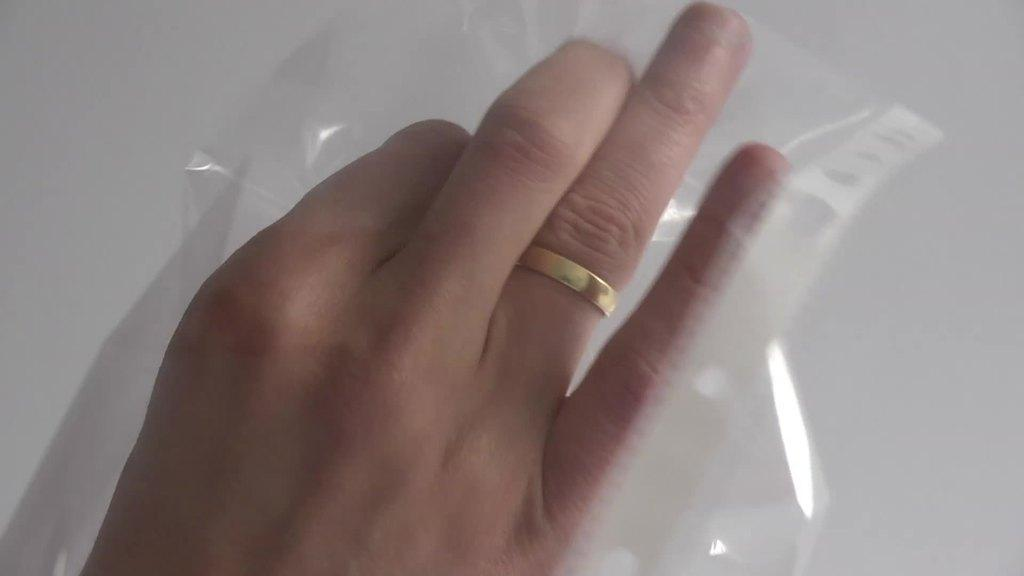What part of a person can be seen in the image? There is a hand of a person in the image. What is on the finger of the hand? There is a ring on the finger of the hand. What else is present in the image besides the hand? There is a cover in the image. What type of kite is being flown near the boundary in the image? There is no kite or boundary present in the image; it only features a hand with a ring and a cover. 